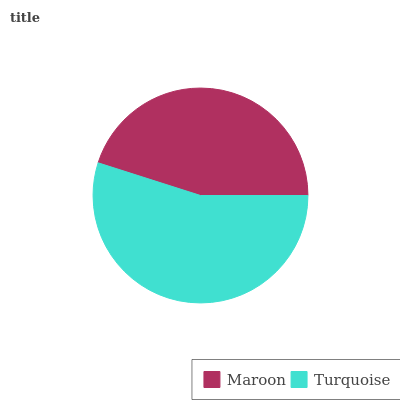Is Maroon the minimum?
Answer yes or no. Yes. Is Turquoise the maximum?
Answer yes or no. Yes. Is Turquoise the minimum?
Answer yes or no. No. Is Turquoise greater than Maroon?
Answer yes or no. Yes. Is Maroon less than Turquoise?
Answer yes or no. Yes. Is Maroon greater than Turquoise?
Answer yes or no. No. Is Turquoise less than Maroon?
Answer yes or no. No. Is Turquoise the high median?
Answer yes or no. Yes. Is Maroon the low median?
Answer yes or no. Yes. Is Maroon the high median?
Answer yes or no. No. Is Turquoise the low median?
Answer yes or no. No. 